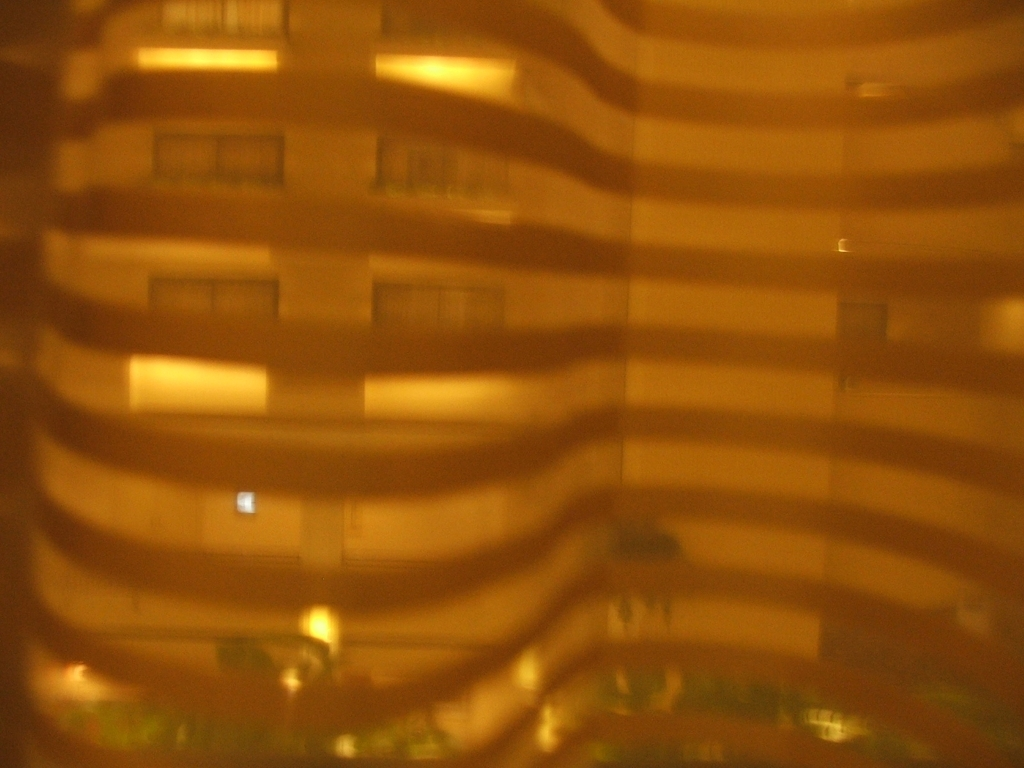Can you describe the quality of this photo? The photo is blurry and has a hazy quality to it, which may be due to camera movement, a dirty lens, or an intentional effect to create a dreamy or old-fashioned look. Does this affect the detail that can be seen? Yes, the blurriness significantly affects the level of detail that can be discerned, making it difficult to identify specific features or textures within the image. 